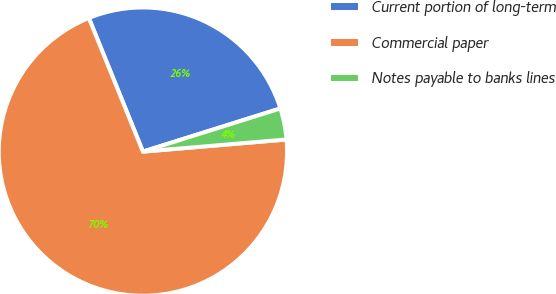<chart> <loc_0><loc_0><loc_500><loc_500><pie_chart><fcel>Current portion of long-term<fcel>Commercial paper<fcel>Notes payable to banks lines<nl><fcel>26.28%<fcel>70.22%<fcel>3.5%<nl></chart> 